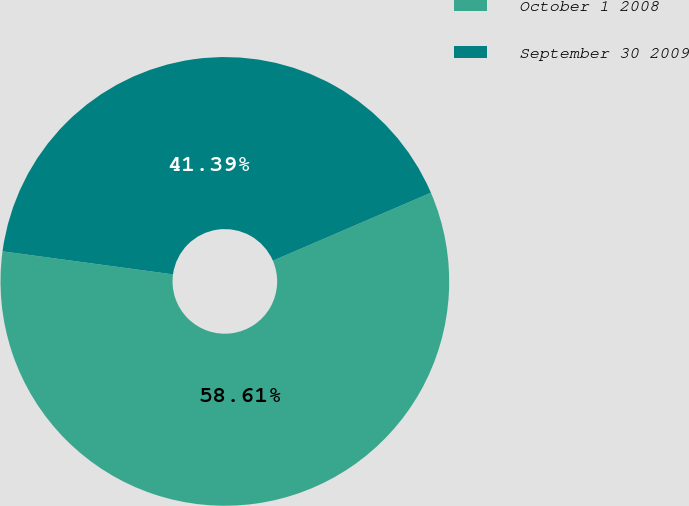Convert chart. <chart><loc_0><loc_0><loc_500><loc_500><pie_chart><fcel>October 1 2008<fcel>September 30 2009<nl><fcel>58.61%<fcel>41.39%<nl></chart> 